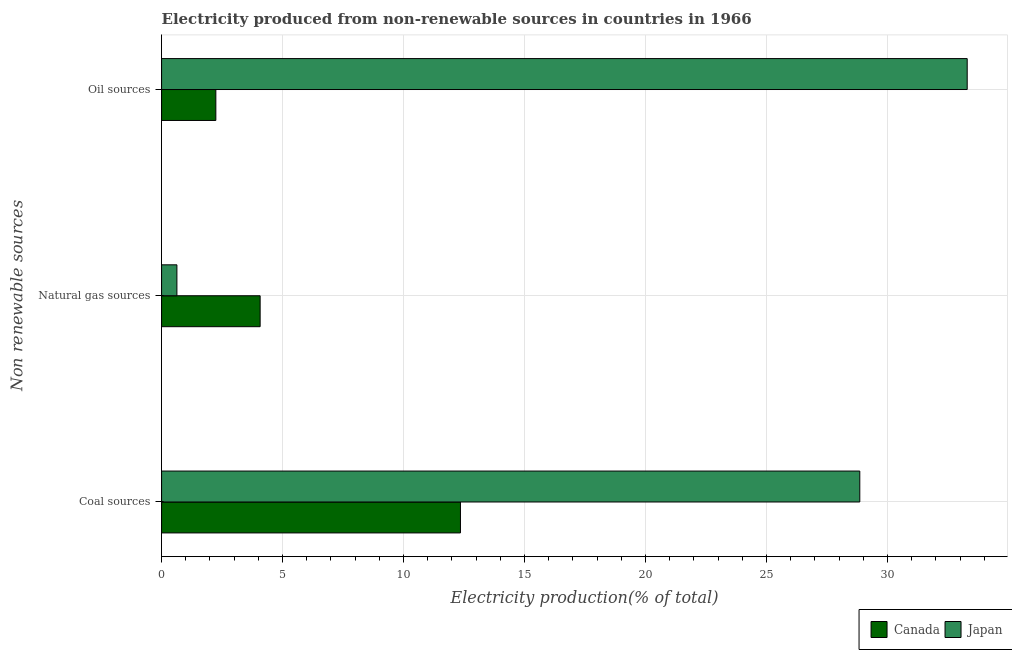How many groups of bars are there?
Make the answer very short. 3. Are the number of bars per tick equal to the number of legend labels?
Provide a succinct answer. Yes. Are the number of bars on each tick of the Y-axis equal?
Offer a very short reply. Yes. How many bars are there on the 1st tick from the bottom?
Your answer should be compact. 2. What is the label of the 3rd group of bars from the top?
Make the answer very short. Coal sources. What is the percentage of electricity produced by natural gas in Japan?
Keep it short and to the point. 0.63. Across all countries, what is the maximum percentage of electricity produced by natural gas?
Your answer should be very brief. 4.07. Across all countries, what is the minimum percentage of electricity produced by oil sources?
Keep it short and to the point. 2.24. What is the total percentage of electricity produced by natural gas in the graph?
Provide a succinct answer. 4.71. What is the difference between the percentage of electricity produced by coal in Japan and that in Canada?
Make the answer very short. 16.5. What is the difference between the percentage of electricity produced by coal in Canada and the percentage of electricity produced by natural gas in Japan?
Your response must be concise. 11.72. What is the average percentage of electricity produced by natural gas per country?
Offer a very short reply. 2.35. What is the difference between the percentage of electricity produced by coal and percentage of electricity produced by natural gas in Japan?
Offer a terse response. 28.22. What is the ratio of the percentage of electricity produced by coal in Canada to that in Japan?
Make the answer very short. 0.43. Is the percentage of electricity produced by oil sources in Japan less than that in Canada?
Offer a very short reply. No. What is the difference between the highest and the second highest percentage of electricity produced by coal?
Provide a short and direct response. 16.5. What is the difference between the highest and the lowest percentage of electricity produced by coal?
Your answer should be very brief. 16.5. Is the sum of the percentage of electricity produced by oil sources in Canada and Japan greater than the maximum percentage of electricity produced by coal across all countries?
Offer a very short reply. Yes. How many countries are there in the graph?
Offer a very short reply. 2. What is the difference between two consecutive major ticks on the X-axis?
Offer a terse response. 5. Does the graph contain any zero values?
Give a very brief answer. No. What is the title of the graph?
Offer a very short reply. Electricity produced from non-renewable sources in countries in 1966. Does "Netherlands" appear as one of the legend labels in the graph?
Offer a terse response. No. What is the label or title of the X-axis?
Your response must be concise. Electricity production(% of total). What is the label or title of the Y-axis?
Ensure brevity in your answer.  Non renewable sources. What is the Electricity production(% of total) of Canada in Coal sources?
Give a very brief answer. 12.35. What is the Electricity production(% of total) in Japan in Coal sources?
Make the answer very short. 28.86. What is the Electricity production(% of total) of Canada in Natural gas sources?
Ensure brevity in your answer.  4.07. What is the Electricity production(% of total) of Japan in Natural gas sources?
Provide a succinct answer. 0.63. What is the Electricity production(% of total) in Canada in Oil sources?
Offer a terse response. 2.24. What is the Electricity production(% of total) of Japan in Oil sources?
Make the answer very short. 33.3. Across all Non renewable sources, what is the maximum Electricity production(% of total) of Canada?
Offer a terse response. 12.35. Across all Non renewable sources, what is the maximum Electricity production(% of total) of Japan?
Keep it short and to the point. 33.3. Across all Non renewable sources, what is the minimum Electricity production(% of total) of Canada?
Provide a short and direct response. 2.24. Across all Non renewable sources, what is the minimum Electricity production(% of total) of Japan?
Your response must be concise. 0.63. What is the total Electricity production(% of total) in Canada in the graph?
Offer a very short reply. 18.67. What is the total Electricity production(% of total) of Japan in the graph?
Your answer should be compact. 62.79. What is the difference between the Electricity production(% of total) in Canada in Coal sources and that in Natural gas sources?
Give a very brief answer. 8.28. What is the difference between the Electricity production(% of total) in Japan in Coal sources and that in Natural gas sources?
Make the answer very short. 28.22. What is the difference between the Electricity production(% of total) of Canada in Coal sources and that in Oil sources?
Offer a very short reply. 10.11. What is the difference between the Electricity production(% of total) of Japan in Coal sources and that in Oil sources?
Provide a succinct answer. -4.44. What is the difference between the Electricity production(% of total) in Canada in Natural gas sources and that in Oil sources?
Your response must be concise. 1.83. What is the difference between the Electricity production(% of total) of Japan in Natural gas sources and that in Oil sources?
Give a very brief answer. -32.66. What is the difference between the Electricity production(% of total) of Canada in Coal sources and the Electricity production(% of total) of Japan in Natural gas sources?
Offer a very short reply. 11.72. What is the difference between the Electricity production(% of total) of Canada in Coal sources and the Electricity production(% of total) of Japan in Oil sources?
Give a very brief answer. -20.94. What is the difference between the Electricity production(% of total) in Canada in Natural gas sources and the Electricity production(% of total) in Japan in Oil sources?
Keep it short and to the point. -29.22. What is the average Electricity production(% of total) of Canada per Non renewable sources?
Offer a very short reply. 6.22. What is the average Electricity production(% of total) in Japan per Non renewable sources?
Provide a short and direct response. 20.93. What is the difference between the Electricity production(% of total) in Canada and Electricity production(% of total) in Japan in Coal sources?
Offer a very short reply. -16.5. What is the difference between the Electricity production(% of total) of Canada and Electricity production(% of total) of Japan in Natural gas sources?
Ensure brevity in your answer.  3.44. What is the difference between the Electricity production(% of total) of Canada and Electricity production(% of total) of Japan in Oil sources?
Ensure brevity in your answer.  -31.05. What is the ratio of the Electricity production(% of total) of Canada in Coal sources to that in Natural gas sources?
Ensure brevity in your answer.  3.03. What is the ratio of the Electricity production(% of total) in Japan in Coal sources to that in Natural gas sources?
Ensure brevity in your answer.  45.52. What is the ratio of the Electricity production(% of total) of Canada in Coal sources to that in Oil sources?
Your response must be concise. 5.51. What is the ratio of the Electricity production(% of total) in Japan in Coal sources to that in Oil sources?
Offer a terse response. 0.87. What is the ratio of the Electricity production(% of total) in Canada in Natural gas sources to that in Oil sources?
Give a very brief answer. 1.82. What is the ratio of the Electricity production(% of total) of Japan in Natural gas sources to that in Oil sources?
Provide a short and direct response. 0.02. What is the difference between the highest and the second highest Electricity production(% of total) of Canada?
Ensure brevity in your answer.  8.28. What is the difference between the highest and the second highest Electricity production(% of total) in Japan?
Provide a succinct answer. 4.44. What is the difference between the highest and the lowest Electricity production(% of total) of Canada?
Provide a succinct answer. 10.11. What is the difference between the highest and the lowest Electricity production(% of total) of Japan?
Make the answer very short. 32.66. 